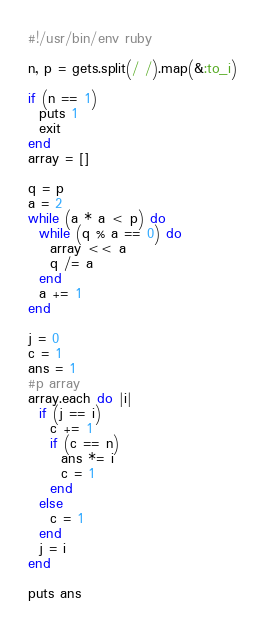<code> <loc_0><loc_0><loc_500><loc_500><_Ruby_>#!/usr/bin/env ruby

n, p = gets.split(/ /).map(&:to_i)

if (n == 1)
  puts 1
  exit
end
array = []

q = p
a = 2
while (a * a < p) do
  while (q % a == 0) do
    array << a
    q /= a
  end
  a += 1
end

j = 0
c = 1
ans = 1
#p array
array.each do |i|
  if (j == i)
    c += 1
    if (c == n)
      ans *= i
      c = 1
    end
  else
    c = 1
  end
  j = i
end

puts ans
</code> 